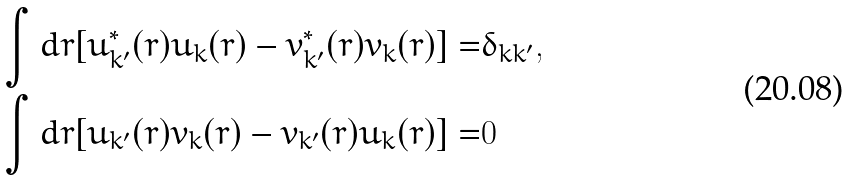<formula> <loc_0><loc_0><loc_500><loc_500>\int d r [ u _ { k ^ { \prime } } ^ { * } ( r ) u _ { k } ( r ) - v _ { k ^ { \prime } } ^ { * } ( r ) v _ { k } ( r ) ] = & \delta _ { k k ^ { \prime } } , \\ \int d r [ u _ { k ^ { \prime } } ( r ) v _ { k } ( r ) - v _ { k ^ { \prime } } ( r ) u _ { k } ( r ) ] = & 0</formula> 